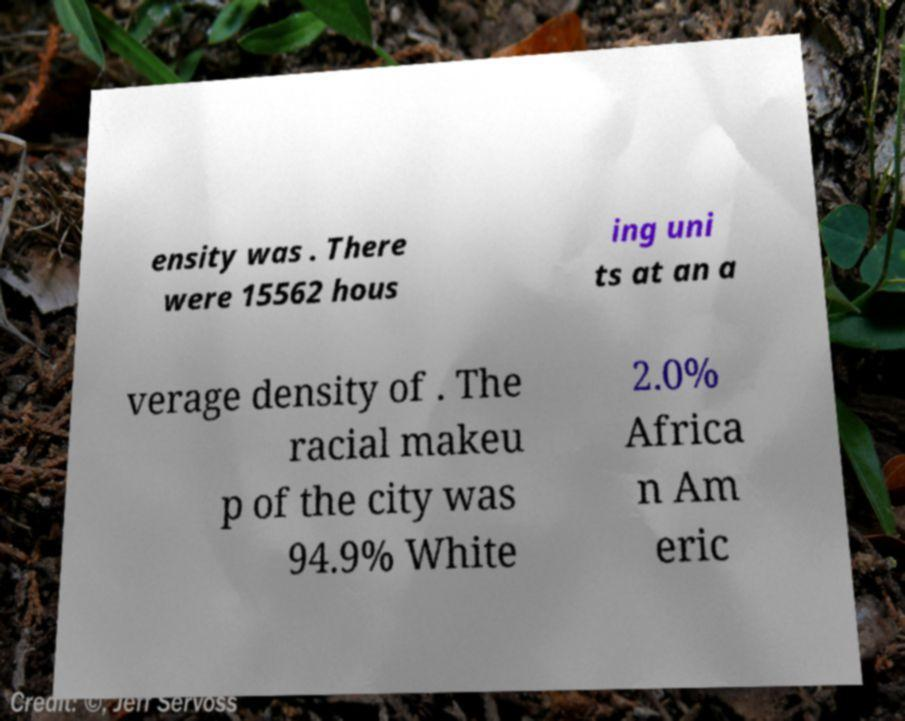There's text embedded in this image that I need extracted. Can you transcribe it verbatim? ensity was . There were 15562 hous ing uni ts at an a verage density of . The racial makeu p of the city was 94.9% White 2.0% Africa n Am eric 